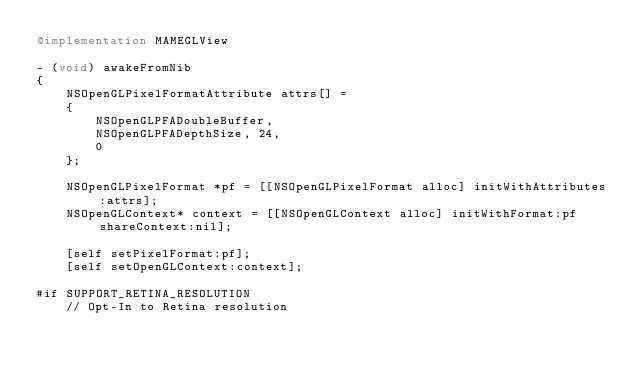<code> <loc_0><loc_0><loc_500><loc_500><_ObjectiveC_>@implementation MAMEGLView

- (void) awakeFromNib
{
	NSOpenGLPixelFormatAttribute attrs[] =
	{
		NSOpenGLPFADoubleBuffer,
		NSOpenGLPFADepthSize, 24,
		0
	};

	NSOpenGLPixelFormat *pf = [[NSOpenGLPixelFormat alloc] initWithAttributes:attrs];
	NSOpenGLContext* context = [[NSOpenGLContext alloc] initWithFormat:pf shareContext:nil];

	[self setPixelFormat:pf];
	[self setOpenGLContext:context];

#if SUPPORT_RETINA_RESOLUTION
	// Opt-In to Retina resolution</code> 